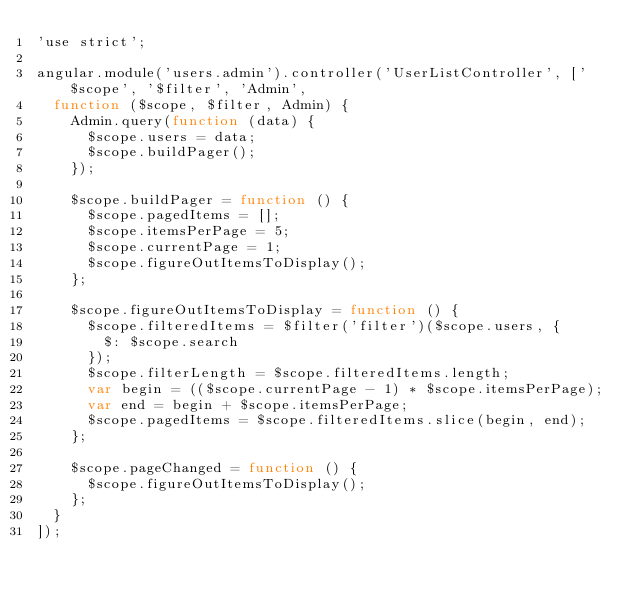<code> <loc_0><loc_0><loc_500><loc_500><_JavaScript_>'use strict';

angular.module('users.admin').controller('UserListController', ['$scope', '$filter', 'Admin',
  function ($scope, $filter, Admin) {
    Admin.query(function (data) {
      $scope.users = data;
      $scope.buildPager();
    });

    $scope.buildPager = function () {
      $scope.pagedItems = [];
      $scope.itemsPerPage = 5;
      $scope.currentPage = 1;
      $scope.figureOutItemsToDisplay();
    };

    $scope.figureOutItemsToDisplay = function () {
      $scope.filteredItems = $filter('filter')($scope.users, {
        $: $scope.search
      });
      $scope.filterLength = $scope.filteredItems.length;
      var begin = (($scope.currentPage - 1) * $scope.itemsPerPage);
      var end = begin + $scope.itemsPerPage;
      $scope.pagedItems = $scope.filteredItems.slice(begin, end);
    };

    $scope.pageChanged = function () {
      $scope.figureOutItemsToDisplay();
    };
  }
]);</code> 